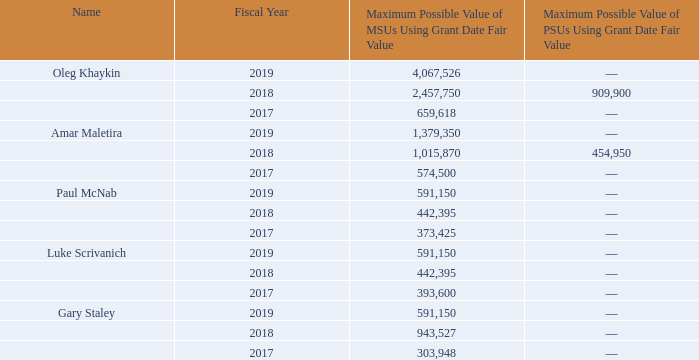The assumptions used to calculate these amounts for fiscal 2019 are set forth under Note 16 of the Notes to Consolidated Financial Statements included in the Company’s Annual Report on Form 10-K for fiscal year 2019 filed with the SEC on August 27, 2019.
(2) Amounts shown do not reflect compensation actually received by the NEO. Instead, the amounts shown in this column represent the grant date fair values of stock options issued pursuant to the Company’s 2003 Equity Incentive Plan and certain inducement grants, computed in accordance with FASB ASC Topic 718. The assumptions used to calculate these amounts for fiscal 2019 are set forth under Note 16 of the Notes to Consolidated Financial Statements included in the Company’s Annual Report on Form 10-K for fiscal year 2019 filed with the SEC on August 27, 2019.
(3) All non-equity incentive plan compensation was paid pursuant to the Variable Pay Plan.
(4) The amounts in the “All Other Compensation” column for fiscal 2019 include: $4,000 401(k) matching contribution by the Company for each NEOs other than Mr. McNab.
(5) The Compensation Committee awarded Mr. Maletira a one-time discretionary bonus in the amount of $180,000 in connection with his work on the AvComm and Wireless acquisition. Please see “Discretionary Bonuses” under the Compensation Discussion and Analysis on page 36 of this proxy statement.
(6) Mr. Staley was awarded a $60,000 sign-on bonus when he joined the Company in February 2017.
The amounts in the salary, bonus, and non-equity incentive plan compensation columns of the Summary Compensation Table reflect actual amounts paid for the relevant years, while the amounts in the stock awards column reflect accounting values. The tables entitled “Outstanding Equity Awards at Fiscal Year-End Table” and “Option Exercises and Stock Vested Table” provide further information on the named executive officers’ potential realizable value and actual value realized with respect to their equity awards. The Summary Compensation Table should be read in conjunction with the Compensation Discussion and Analysis and the subsequent tables and narrative descriptions.
How much was Gary Staley's sign-on bonus when he joined the company in February 2017?
Answer scale should be: thousand. $60,000. What was the maximum possible value of MSU's using grant date fair value for Oleg Khaykin in 2018? 2,457,750. What was the maximum possible value of MSU's using grant date fair value for Paul McNab in 2019? 591,150. What was the change in maximum possible value of MSU's using grant date fair value for Paul McNab between 2017 and 2018 as a percentage?
Answer scale should be: percent. (442,395-373,425)/373,425
Answer: 18.47. What is the difference between the maximum possible value of PSUs in 2018 between Oleg Khaykin and Amar Maletira? (909,900-454,950)
Answer: 454950. How much does the top 2 maximum possible value of MSUs in 2019 add up to? (4,067,526+1,379,350)
Answer: 5446876. 